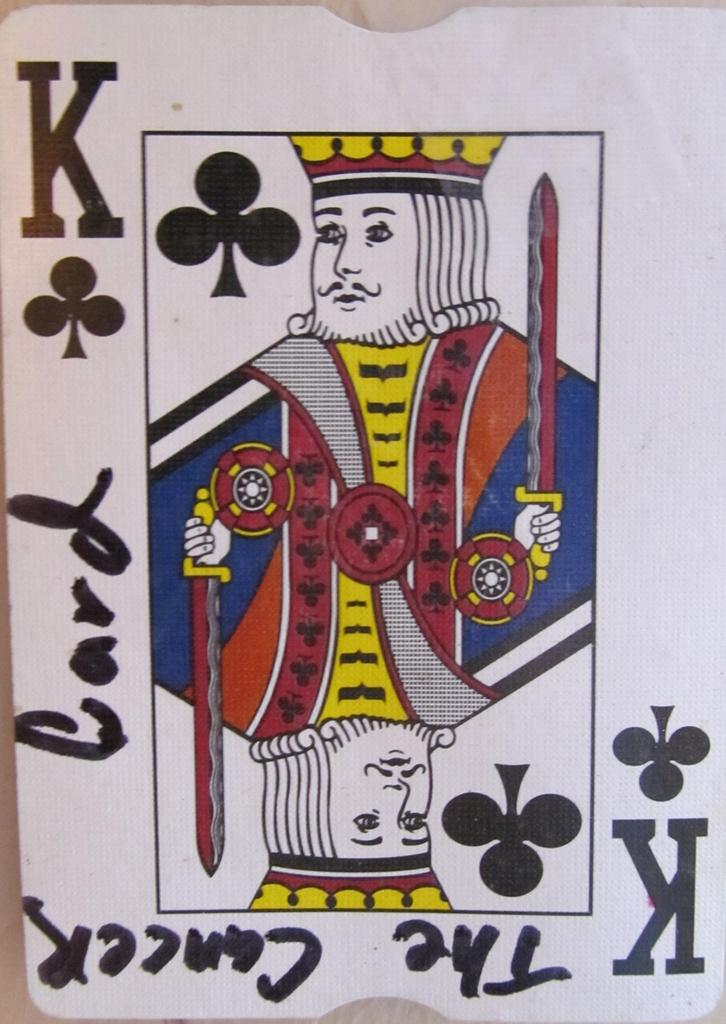<image>
Create a compact narrative representing the image presented. A king playing card is dubbed the cancer card. 